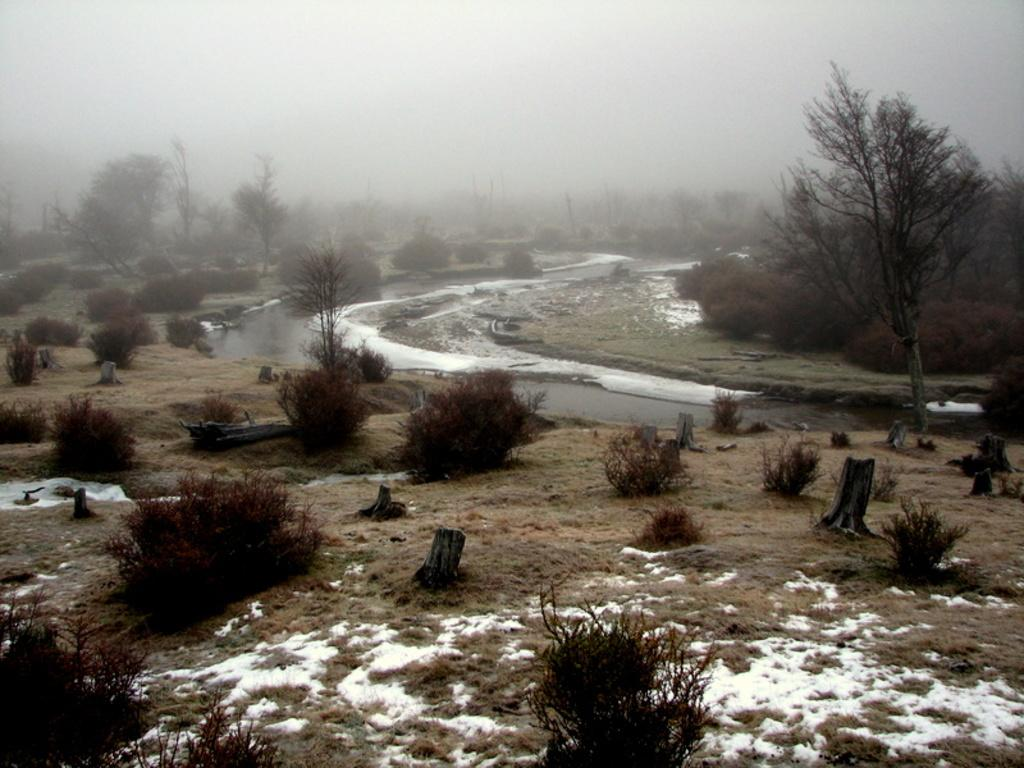What is located in the foreground of the image? There are plants and snow in the foreground of the image. What can be seen on the ground in the foreground of the image? The ground is visible in the foreground of the image. What is visible in the background of the image? There is a river, trees, and the sky in the background of the image. How is the sky depicted in the image? The sky is visible in the background of the image and is covered with fog. What type of doll can be seen receiving approval from the river in the image? There is no doll or approval depicted in the image; it features plants, snow, a river, trees, and a foggy sky. What is the view from the river in the image? The image does not provide a view from the river, as it is a static image and not a perspective. 